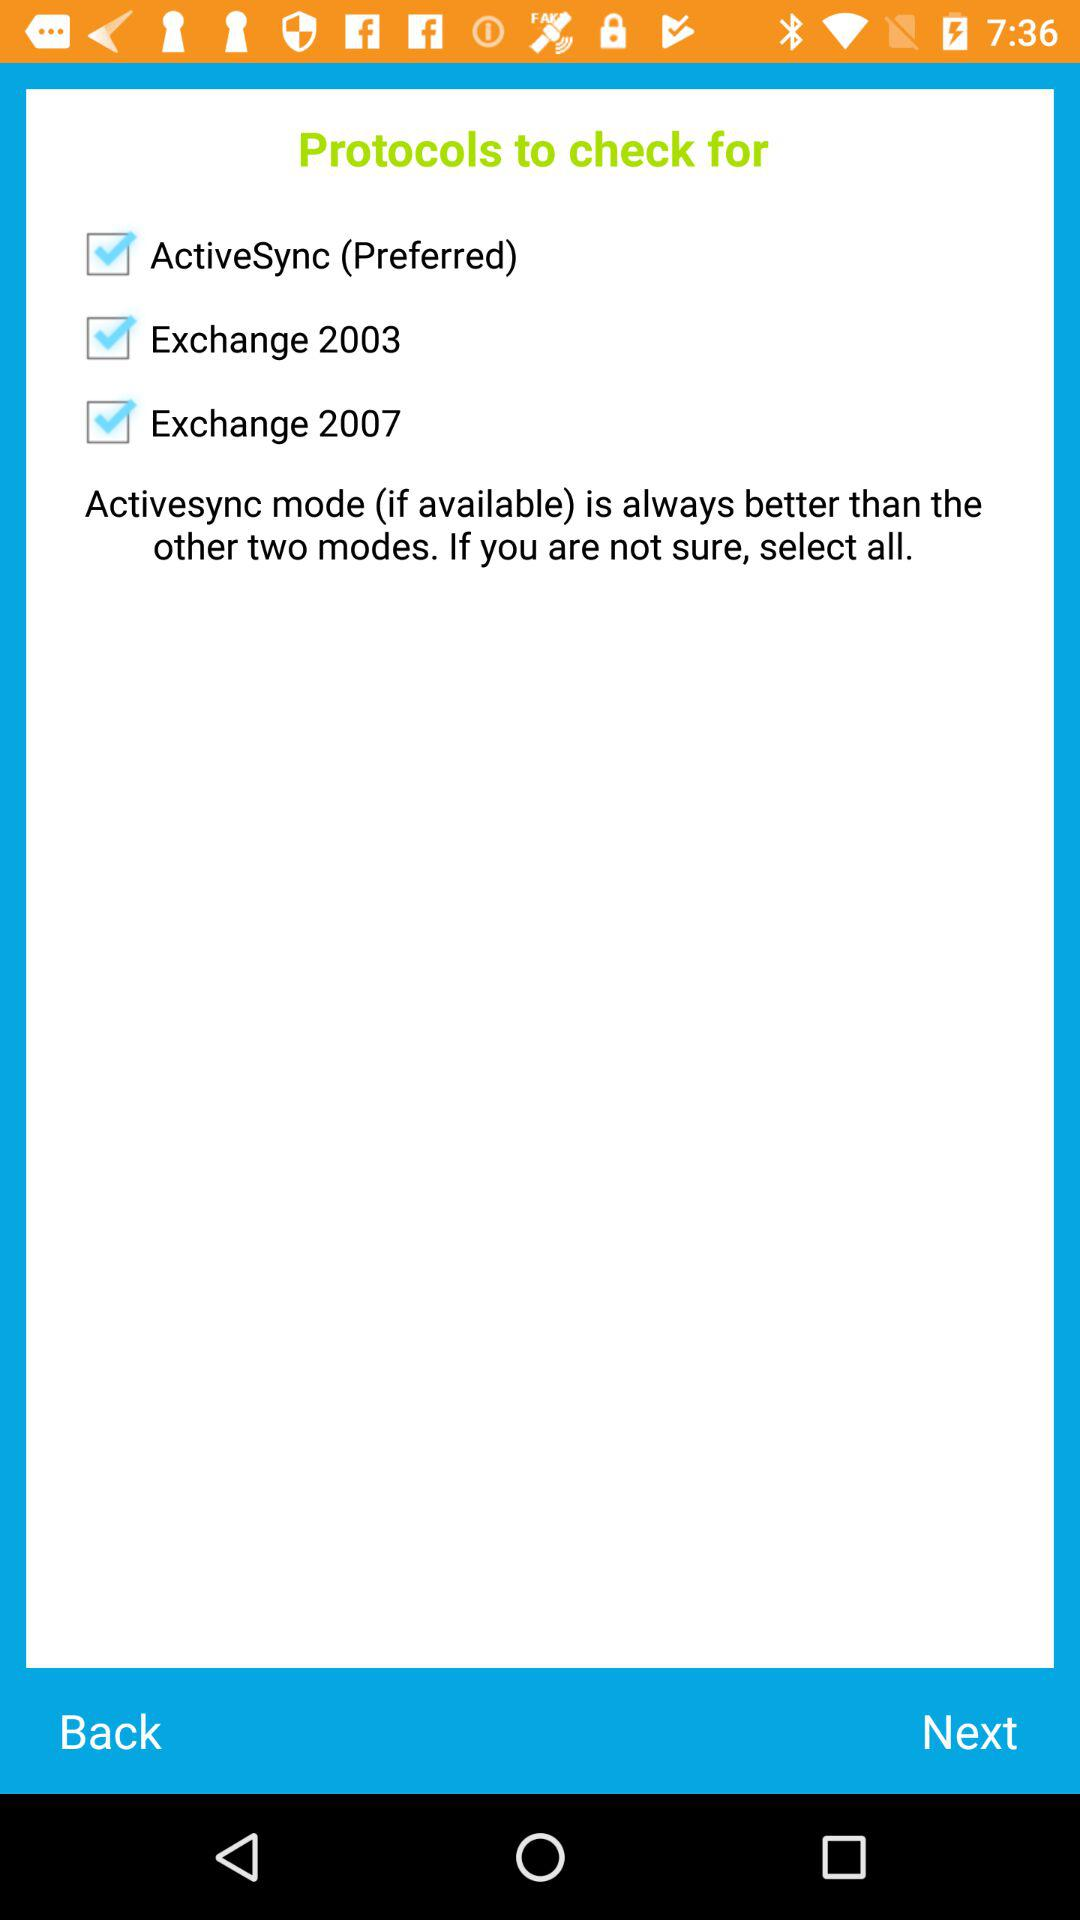What are the selected modes for checking protocols? The selected modes are "ActiveSync (Preferred)", "Exchange 2003", and "Exchange 2007". 